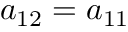Convert formula to latex. <formula><loc_0><loc_0><loc_500><loc_500>a _ { 1 2 } = a _ { 1 1 }</formula> 